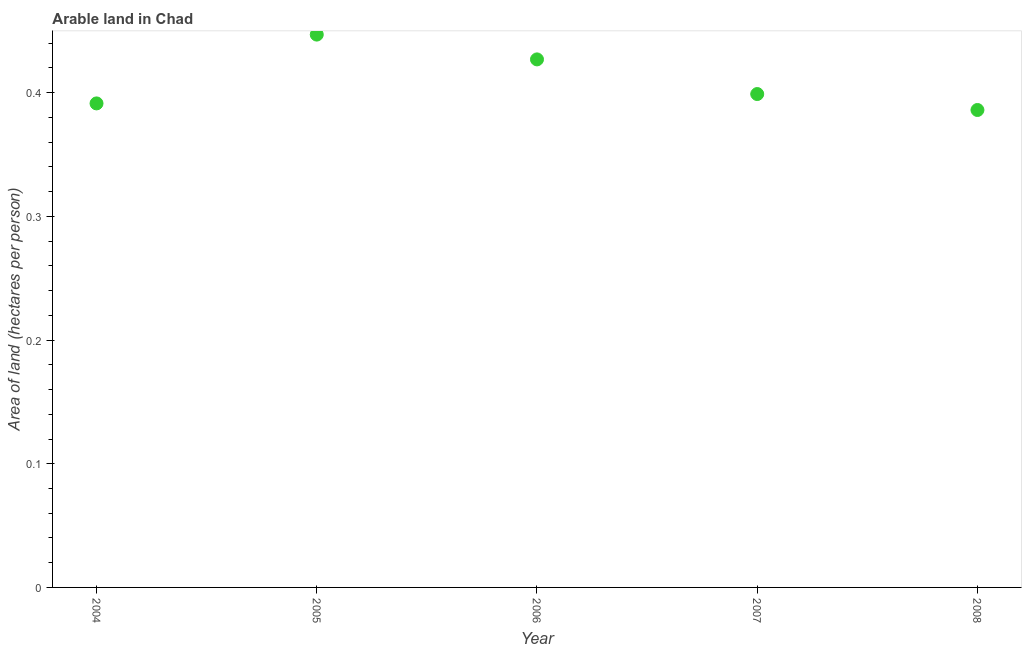What is the area of arable land in 2005?
Offer a very short reply. 0.45. Across all years, what is the maximum area of arable land?
Offer a terse response. 0.45. Across all years, what is the minimum area of arable land?
Your answer should be very brief. 0.39. In which year was the area of arable land minimum?
Your answer should be very brief. 2008. What is the sum of the area of arable land?
Your answer should be compact. 2.05. What is the difference between the area of arable land in 2004 and 2005?
Your answer should be very brief. -0.06. What is the average area of arable land per year?
Your answer should be compact. 0.41. What is the median area of arable land?
Ensure brevity in your answer.  0.4. What is the ratio of the area of arable land in 2006 to that in 2007?
Your answer should be very brief. 1.07. Is the area of arable land in 2004 less than that in 2006?
Offer a very short reply. Yes. What is the difference between the highest and the second highest area of arable land?
Provide a succinct answer. 0.02. Is the sum of the area of arable land in 2004 and 2006 greater than the maximum area of arable land across all years?
Make the answer very short. Yes. What is the difference between the highest and the lowest area of arable land?
Give a very brief answer. 0.06. In how many years, is the area of arable land greater than the average area of arable land taken over all years?
Your answer should be very brief. 2. Does the area of arable land monotonically increase over the years?
Give a very brief answer. No. How many years are there in the graph?
Give a very brief answer. 5. Does the graph contain any zero values?
Offer a very short reply. No. Does the graph contain grids?
Ensure brevity in your answer.  No. What is the title of the graph?
Keep it short and to the point. Arable land in Chad. What is the label or title of the X-axis?
Your response must be concise. Year. What is the label or title of the Y-axis?
Provide a short and direct response. Area of land (hectares per person). What is the Area of land (hectares per person) in 2004?
Keep it short and to the point. 0.39. What is the Area of land (hectares per person) in 2005?
Provide a succinct answer. 0.45. What is the Area of land (hectares per person) in 2006?
Give a very brief answer. 0.43. What is the Area of land (hectares per person) in 2007?
Keep it short and to the point. 0.4. What is the Area of land (hectares per person) in 2008?
Give a very brief answer. 0.39. What is the difference between the Area of land (hectares per person) in 2004 and 2005?
Keep it short and to the point. -0.06. What is the difference between the Area of land (hectares per person) in 2004 and 2006?
Give a very brief answer. -0.04. What is the difference between the Area of land (hectares per person) in 2004 and 2007?
Give a very brief answer. -0.01. What is the difference between the Area of land (hectares per person) in 2004 and 2008?
Your response must be concise. 0.01. What is the difference between the Area of land (hectares per person) in 2005 and 2006?
Make the answer very short. 0.02. What is the difference between the Area of land (hectares per person) in 2005 and 2007?
Ensure brevity in your answer.  0.05. What is the difference between the Area of land (hectares per person) in 2005 and 2008?
Make the answer very short. 0.06. What is the difference between the Area of land (hectares per person) in 2006 and 2007?
Your answer should be compact. 0.03. What is the difference between the Area of land (hectares per person) in 2006 and 2008?
Your answer should be compact. 0.04. What is the difference between the Area of land (hectares per person) in 2007 and 2008?
Make the answer very short. 0.01. What is the ratio of the Area of land (hectares per person) in 2004 to that in 2005?
Your answer should be very brief. 0.88. What is the ratio of the Area of land (hectares per person) in 2004 to that in 2006?
Provide a short and direct response. 0.92. What is the ratio of the Area of land (hectares per person) in 2005 to that in 2006?
Provide a short and direct response. 1.05. What is the ratio of the Area of land (hectares per person) in 2005 to that in 2007?
Ensure brevity in your answer.  1.12. What is the ratio of the Area of land (hectares per person) in 2005 to that in 2008?
Your response must be concise. 1.16. What is the ratio of the Area of land (hectares per person) in 2006 to that in 2007?
Offer a terse response. 1.07. What is the ratio of the Area of land (hectares per person) in 2006 to that in 2008?
Your response must be concise. 1.11. What is the ratio of the Area of land (hectares per person) in 2007 to that in 2008?
Offer a very short reply. 1.03. 